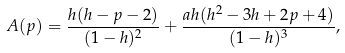Convert formula to latex. <formula><loc_0><loc_0><loc_500><loc_500>A ( p ) = \frac { h ( h - p - 2 ) } { ( 1 - h ) ^ { 2 } } + \frac { a h ( h ^ { 2 } - 3 h + 2 p + 4 ) } { ( 1 - h ) ^ { 3 } } ,</formula> 